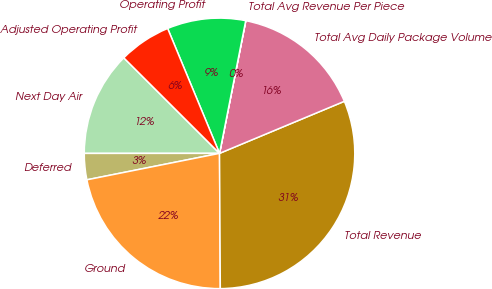<chart> <loc_0><loc_0><loc_500><loc_500><pie_chart><fcel>Next Day Air<fcel>Deferred<fcel>Ground<fcel>Total Revenue<fcel>Total Avg Daily Package Volume<fcel>Total Avg Revenue Per Piece<fcel>Operating Profit<fcel>Adjusted Operating Profit<nl><fcel>12.49%<fcel>3.13%<fcel>21.96%<fcel>31.2%<fcel>15.6%<fcel>0.01%<fcel>9.37%<fcel>6.25%<nl></chart> 